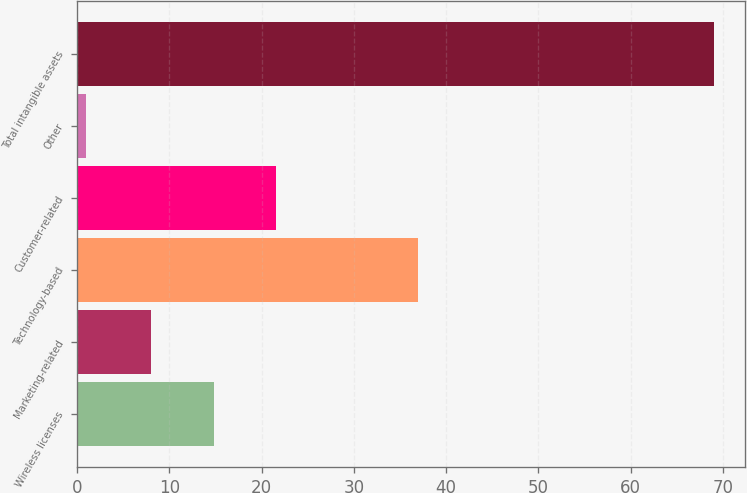Convert chart to OTSL. <chart><loc_0><loc_0><loc_500><loc_500><bar_chart><fcel>Wireless licenses<fcel>Marketing-related<fcel>Technology-based<fcel>Customer-related<fcel>Other<fcel>Total intangible assets<nl><fcel>14.8<fcel>8<fcel>37<fcel>21.6<fcel>1<fcel>69<nl></chart> 